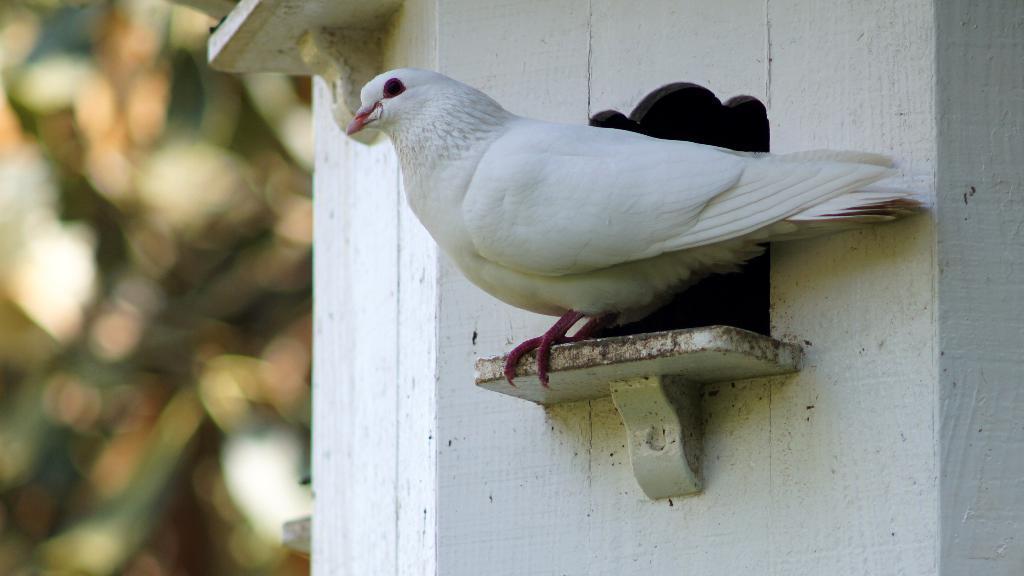Could you give a brief overview of what you see in this image? In this image we can see a pigeon on a birdhouse. In the background it is blur. 